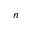Convert formula to latex. <formula><loc_0><loc_0><loc_500><loc_500>n</formula> 